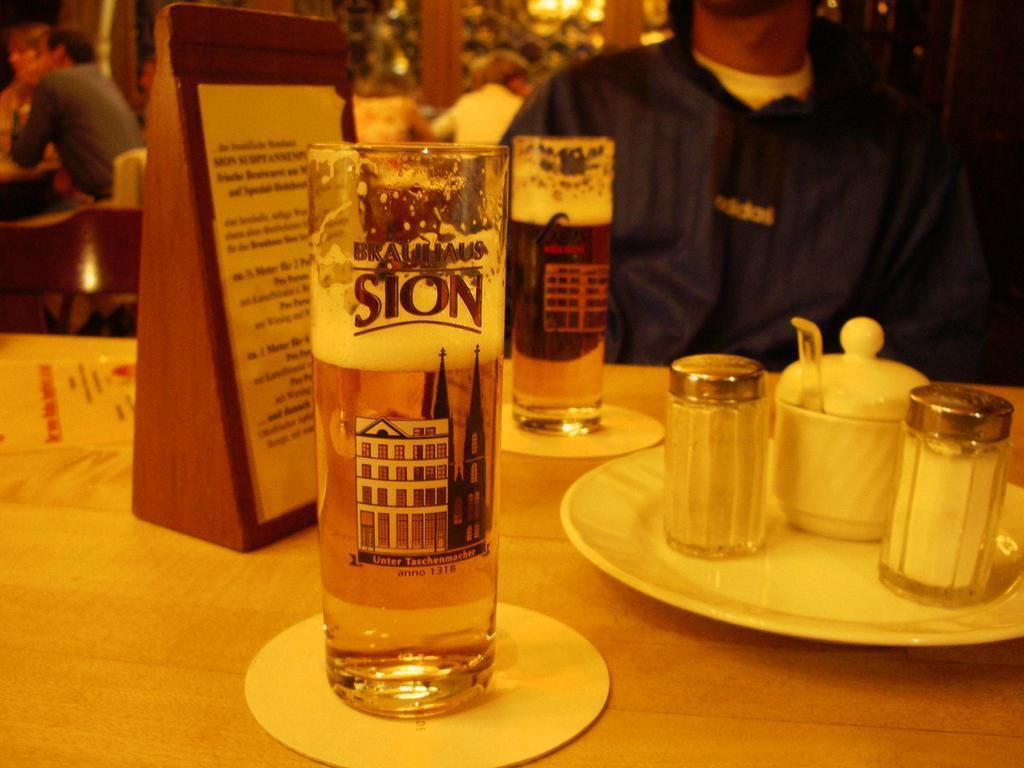Provide a one-sentence caption for the provided image. A tall glass withBrauhaus Sion printed on it about two thirds full of liquid on a table. 